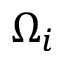Convert formula to latex. <formula><loc_0><loc_0><loc_500><loc_500>\Omega _ { i }</formula> 